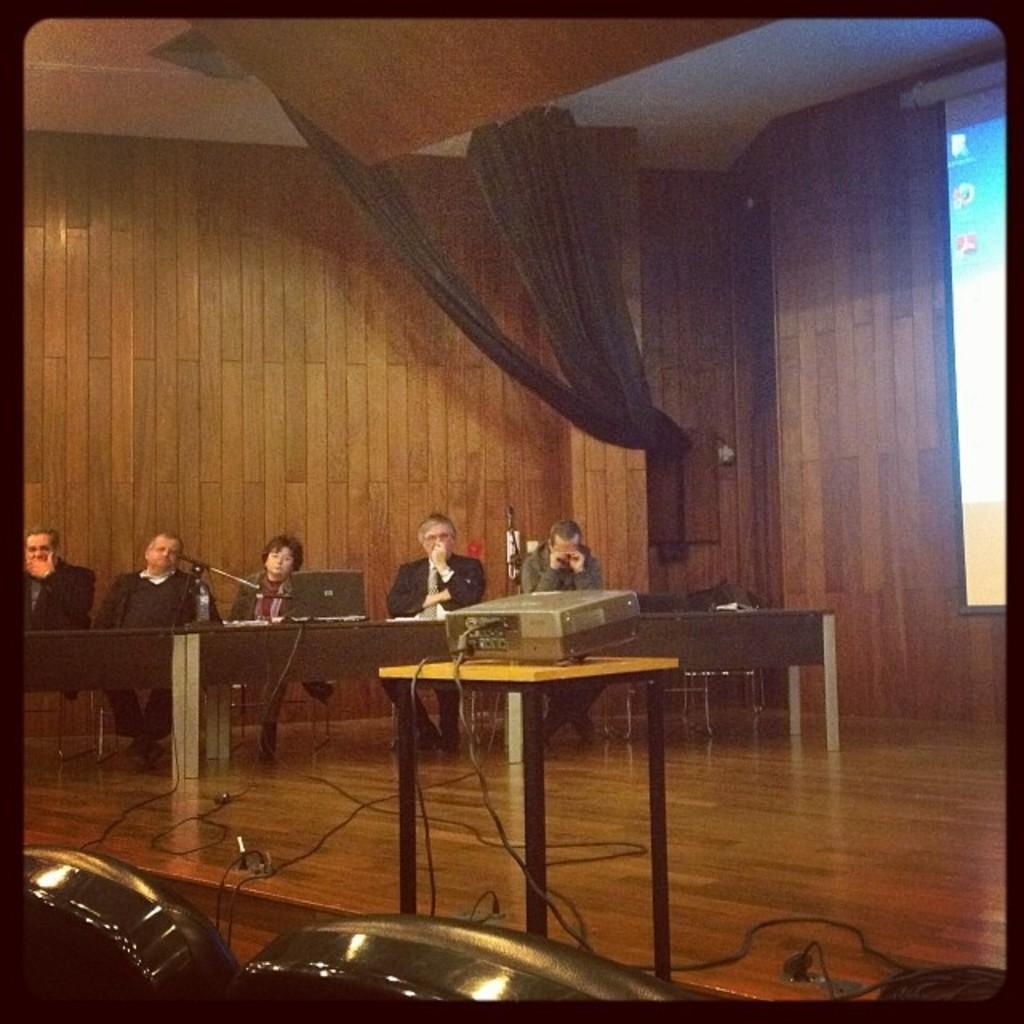In one or two sentences, can you explain what this image depicts? In the image we can see there are people who are sitting on the chair in front of them there is a table on which there are laptops and they are sitting on the stage and there is a projector and its flashing a light on the screen. 